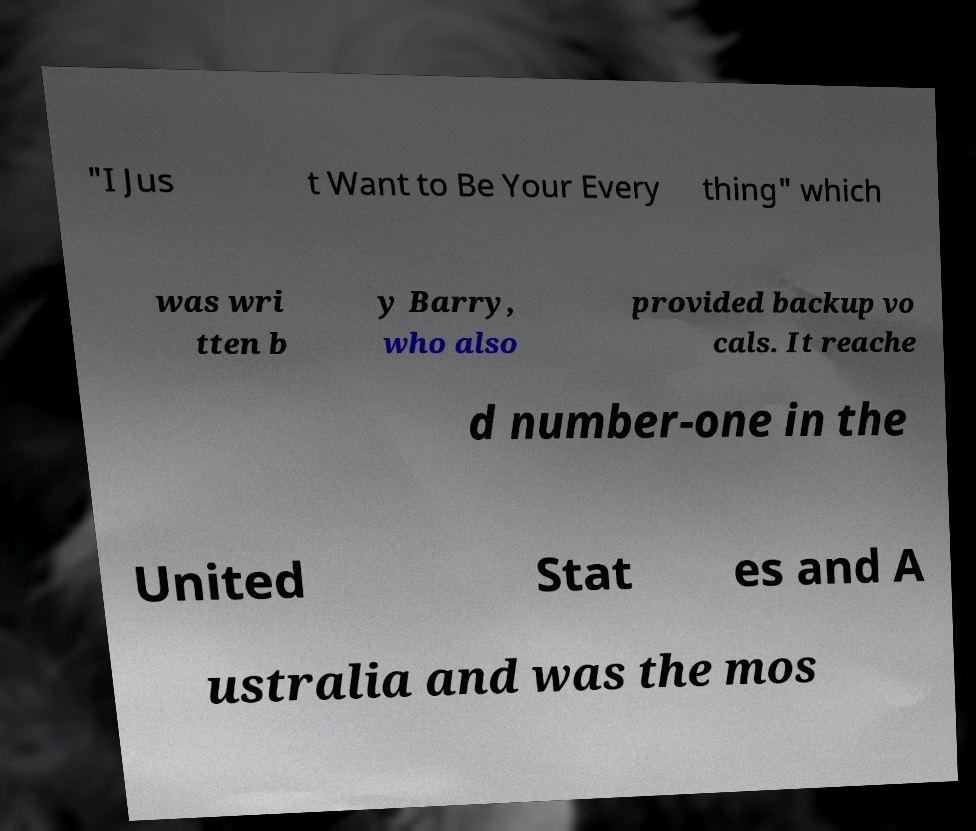There's text embedded in this image that I need extracted. Can you transcribe it verbatim? "I Jus t Want to Be Your Every thing" which was wri tten b y Barry, who also provided backup vo cals. It reache d number-one in the United Stat es and A ustralia and was the mos 